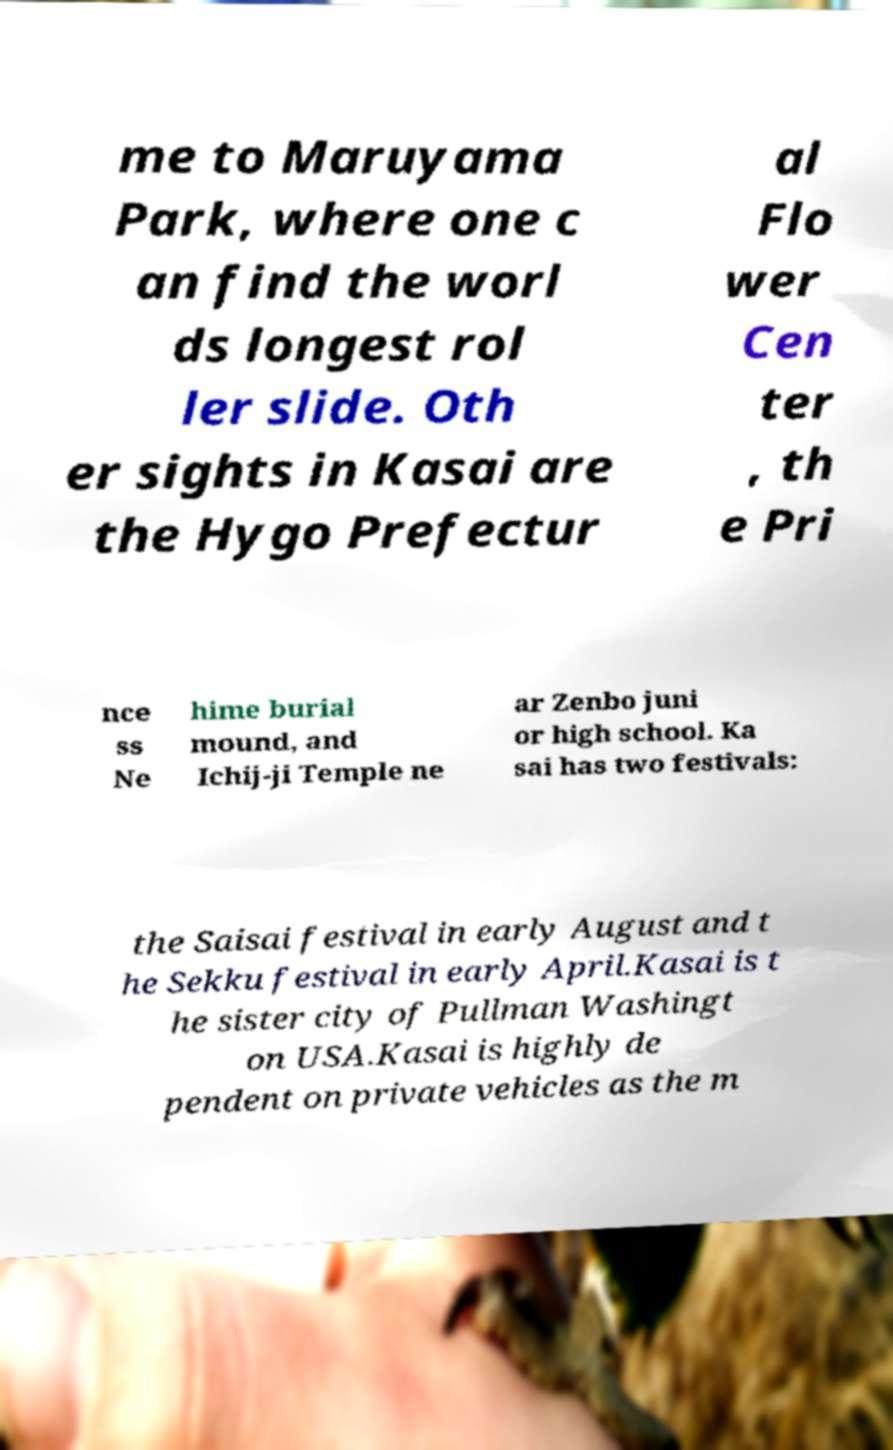What messages or text are displayed in this image? I need them in a readable, typed format. me to Maruyama Park, where one c an find the worl ds longest rol ler slide. Oth er sights in Kasai are the Hygo Prefectur al Flo wer Cen ter , th e Pri nce ss Ne hime burial mound, and Ichij-ji Temple ne ar Zenbo juni or high school. Ka sai has two festivals: the Saisai festival in early August and t he Sekku festival in early April.Kasai is t he sister city of Pullman Washingt on USA.Kasai is highly de pendent on private vehicles as the m 